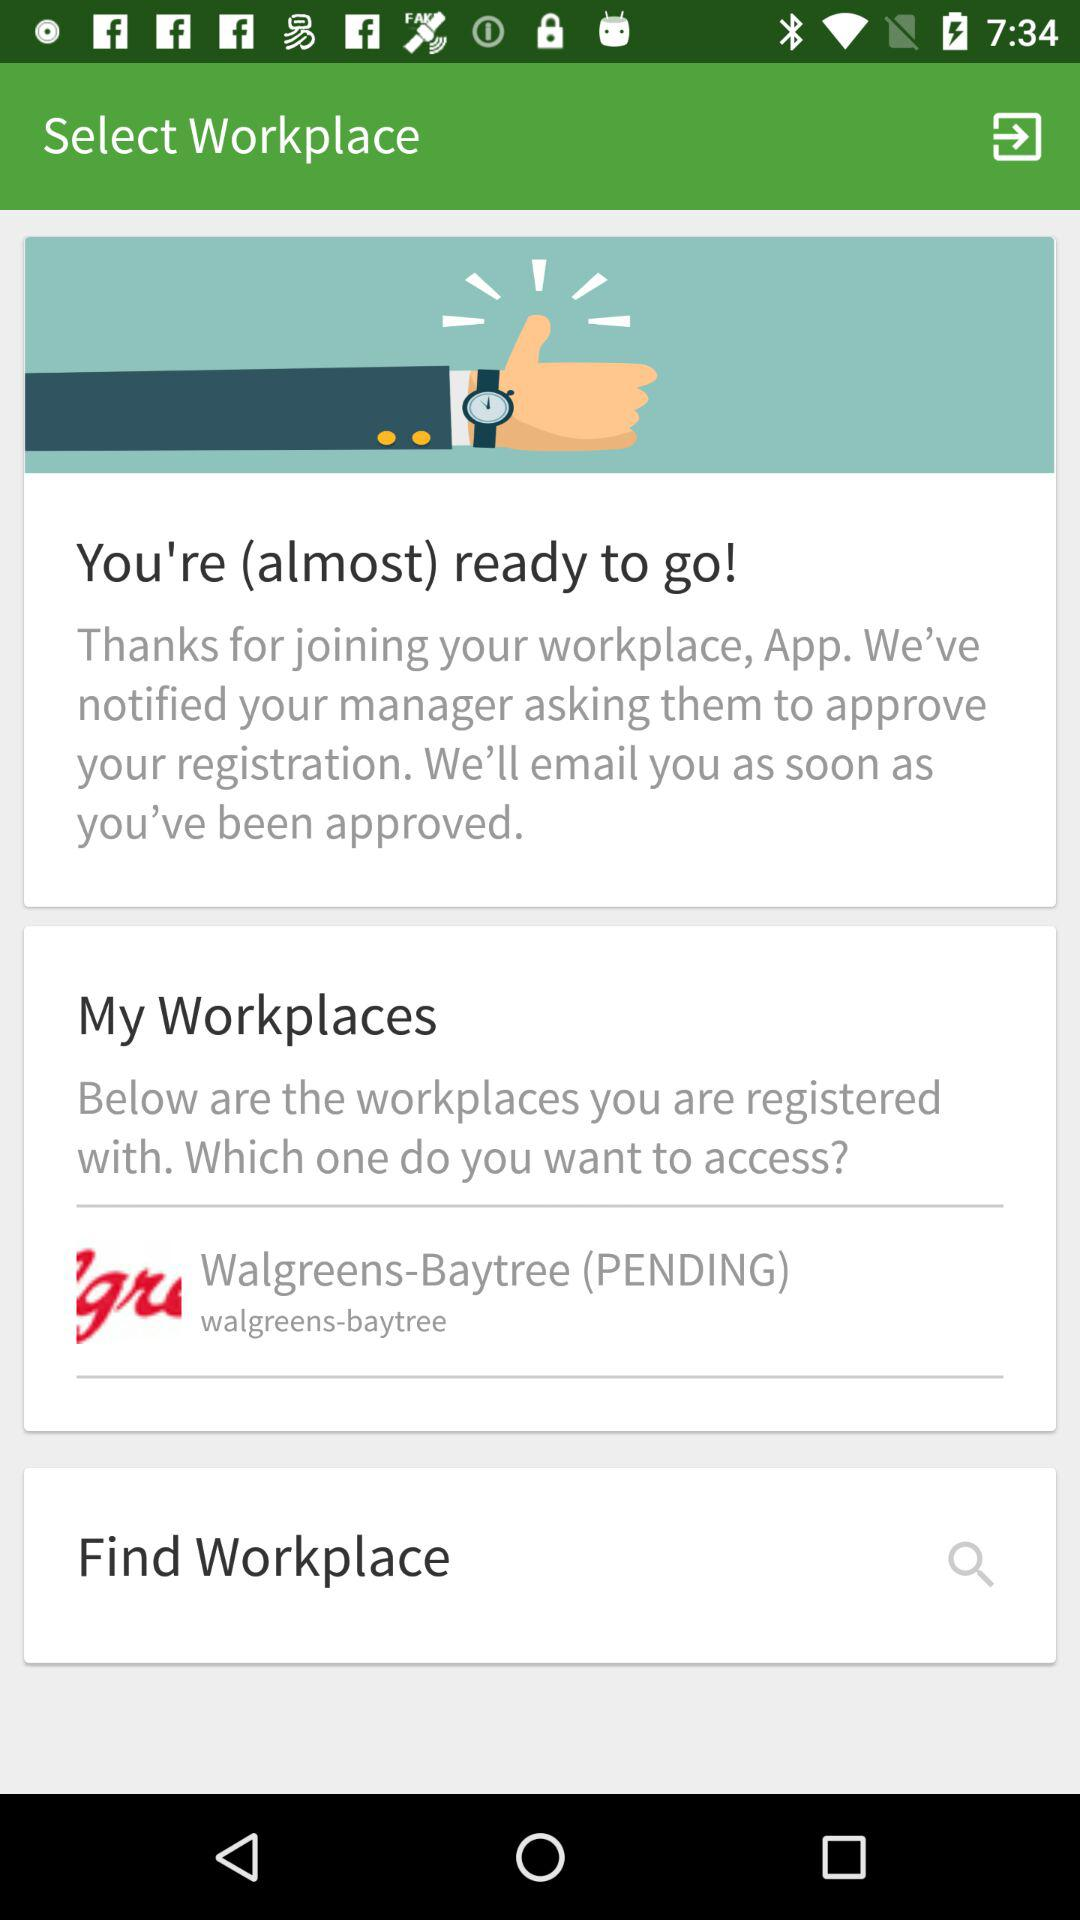How many workplaces are pending approval?
Answer the question using a single word or phrase. 1 